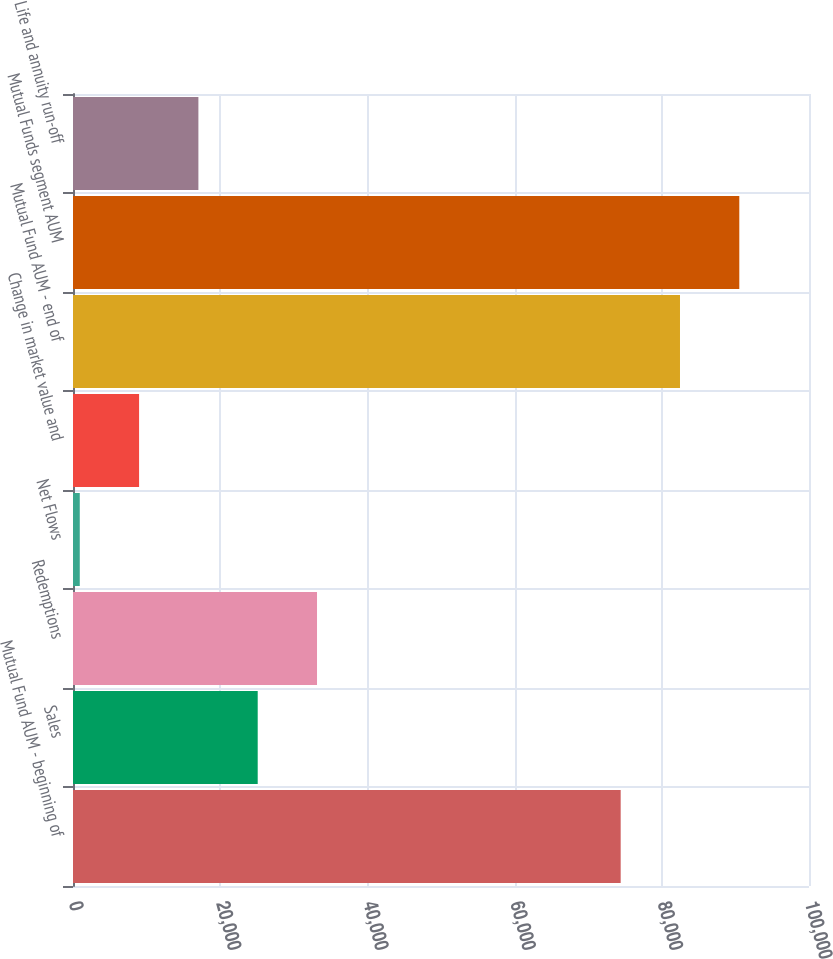<chart> <loc_0><loc_0><loc_500><loc_500><bar_chart><fcel>Mutual Fund AUM - beginning of<fcel>Sales<fcel>Redemptions<fcel>Net Flows<fcel>Change in market value and<fcel>Mutual Fund AUM - end of<fcel>Mutual Funds segment AUM<fcel>Life and annuity run-off<nl><fcel>74413<fcel>25096.1<fcel>33154.8<fcel>920<fcel>8978.7<fcel>82471.7<fcel>90530.4<fcel>17037.4<nl></chart> 